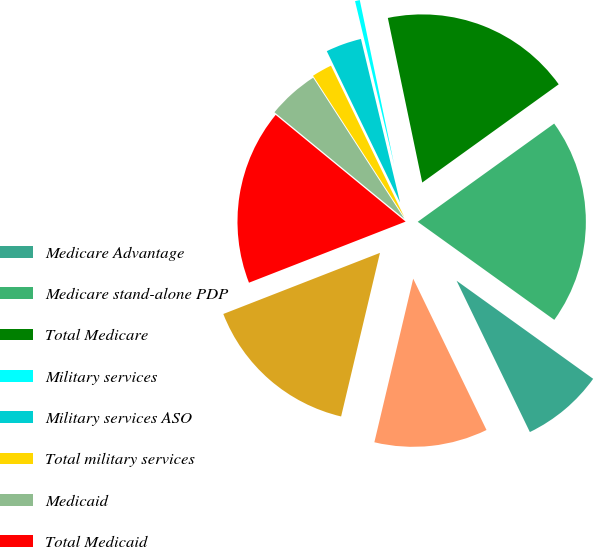<chart> <loc_0><loc_0><loc_500><loc_500><pie_chart><fcel>Medicare Advantage<fcel>Medicare stand-alone PDP<fcel>Total Medicare<fcel>Military services<fcel>Military services ASO<fcel>Total military services<fcel>Medicaid<fcel>Total Medicaid<fcel>Total Government<fcel>Fully-insured<nl><fcel>7.91%<fcel>19.84%<fcel>18.35%<fcel>0.46%<fcel>3.44%<fcel>1.95%<fcel>4.93%<fcel>16.86%<fcel>15.37%<fcel>10.89%<nl></chart> 